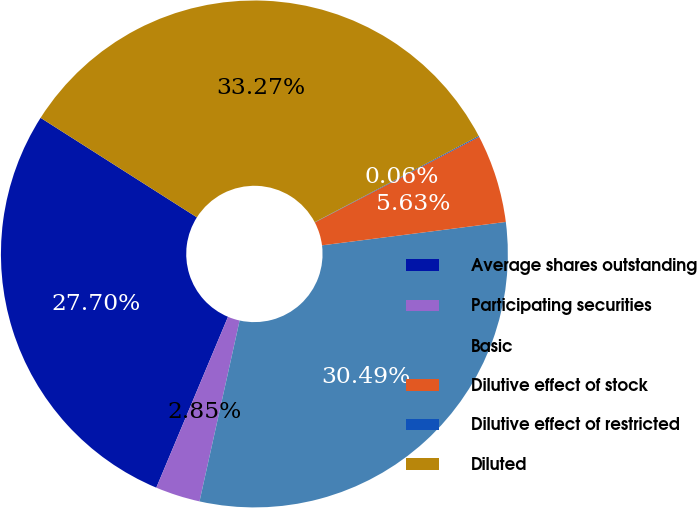Convert chart to OTSL. <chart><loc_0><loc_0><loc_500><loc_500><pie_chart><fcel>Average shares outstanding<fcel>Participating securities<fcel>Basic<fcel>Dilutive effect of stock<fcel>Dilutive effect of restricted<fcel>Diluted<nl><fcel>27.7%<fcel>2.85%<fcel>30.49%<fcel>5.63%<fcel>0.06%<fcel>33.27%<nl></chart> 